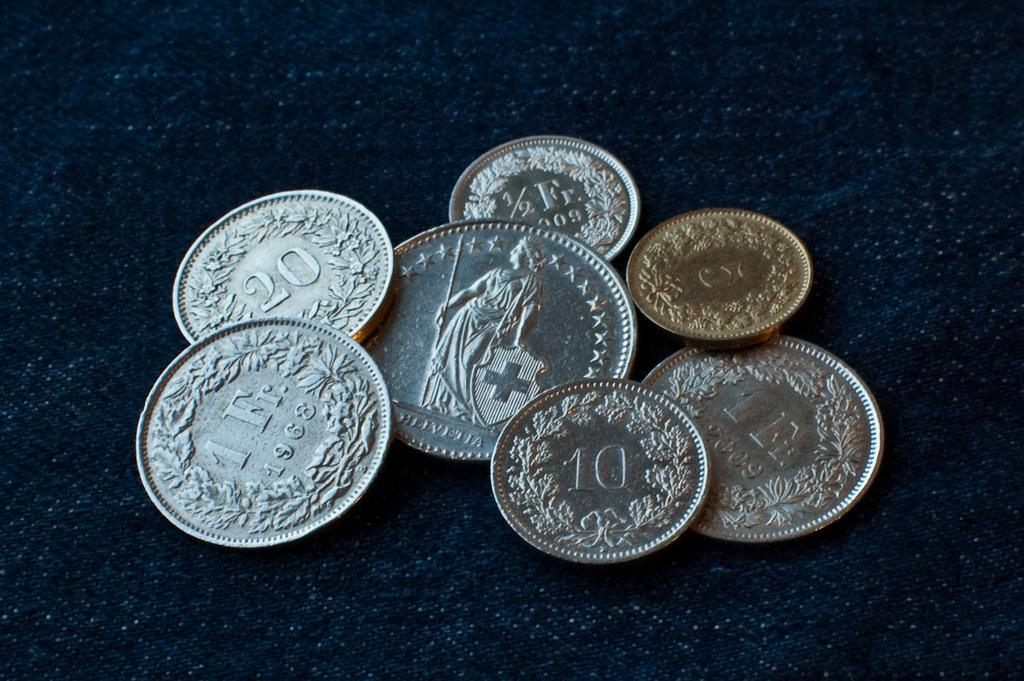<image>
Summarize the visual content of the image. Seven metallic coins next to each other including one from 1968. 